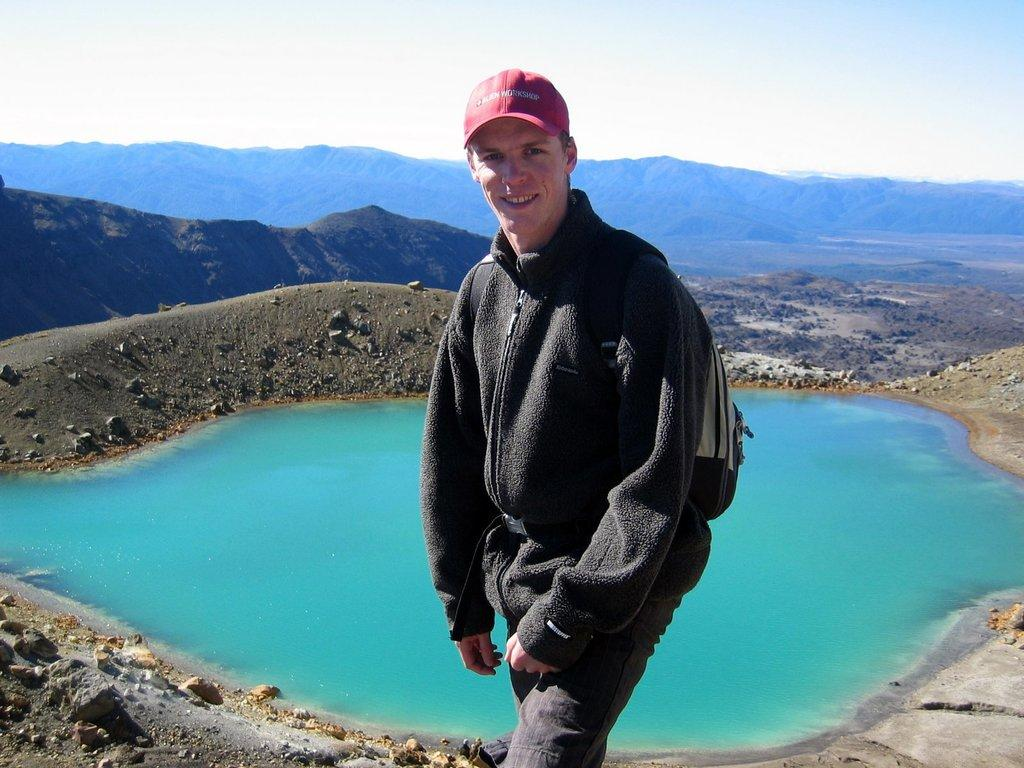What is the man in the image wearing? The man is wearing a bag and a cap. What can be seen in the background of the image? There is a large water body, stones, and hills visible in the background. How is the sky depicted in the image? The sky is cloudy in the image. What type of degree is the man holding in the image? There is no degree visible in the image; the man is wearing a bag and a cap. Is there any snow present in the image? No, there is no snow present in the image. 